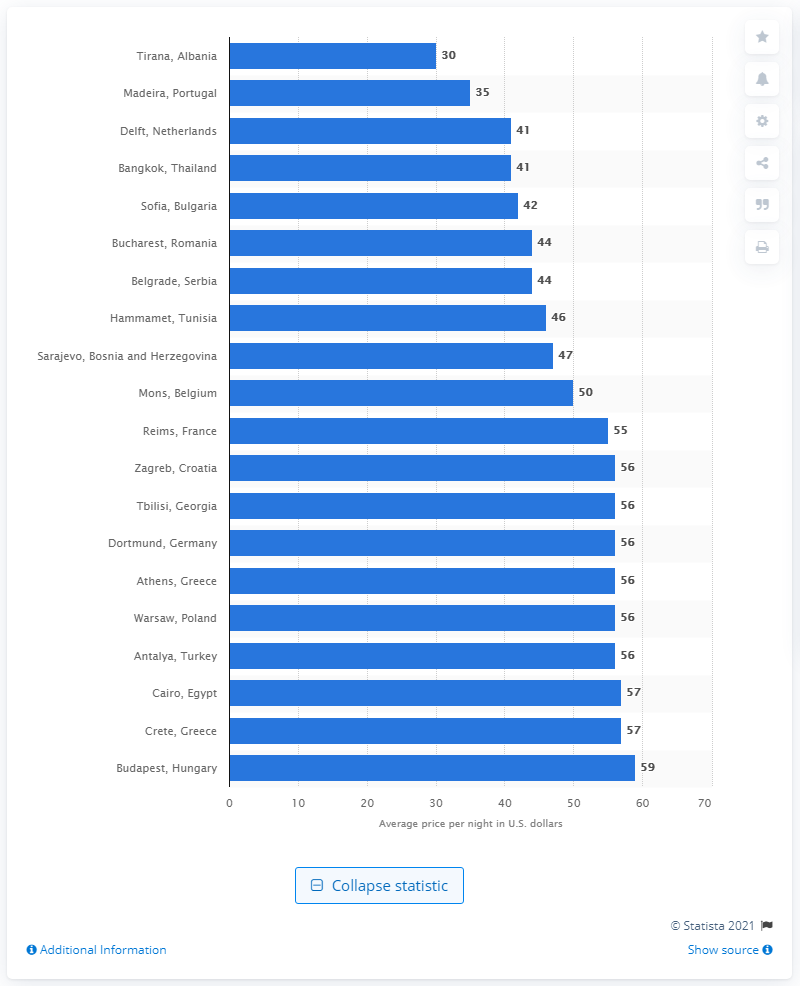Point out several critical features in this image. According to the data, the average cost of a night in Tirana was approximately 30 USD. 